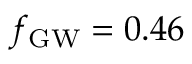<formula> <loc_0><loc_0><loc_500><loc_500>{ f _ { G W } } = 0 . 4 6</formula> 